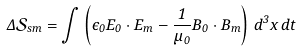Convert formula to latex. <formula><loc_0><loc_0><loc_500><loc_500>\Delta \mathcal { S } _ { s m } = \int \left ( \epsilon _ { 0 } { E _ { 0 } } \cdot { E _ { m } } - \frac { 1 } { \mu _ { 0 } } { B _ { 0 } } \cdot { B _ { m } } \right ) \, d ^ { 3 } x \, d t</formula> 